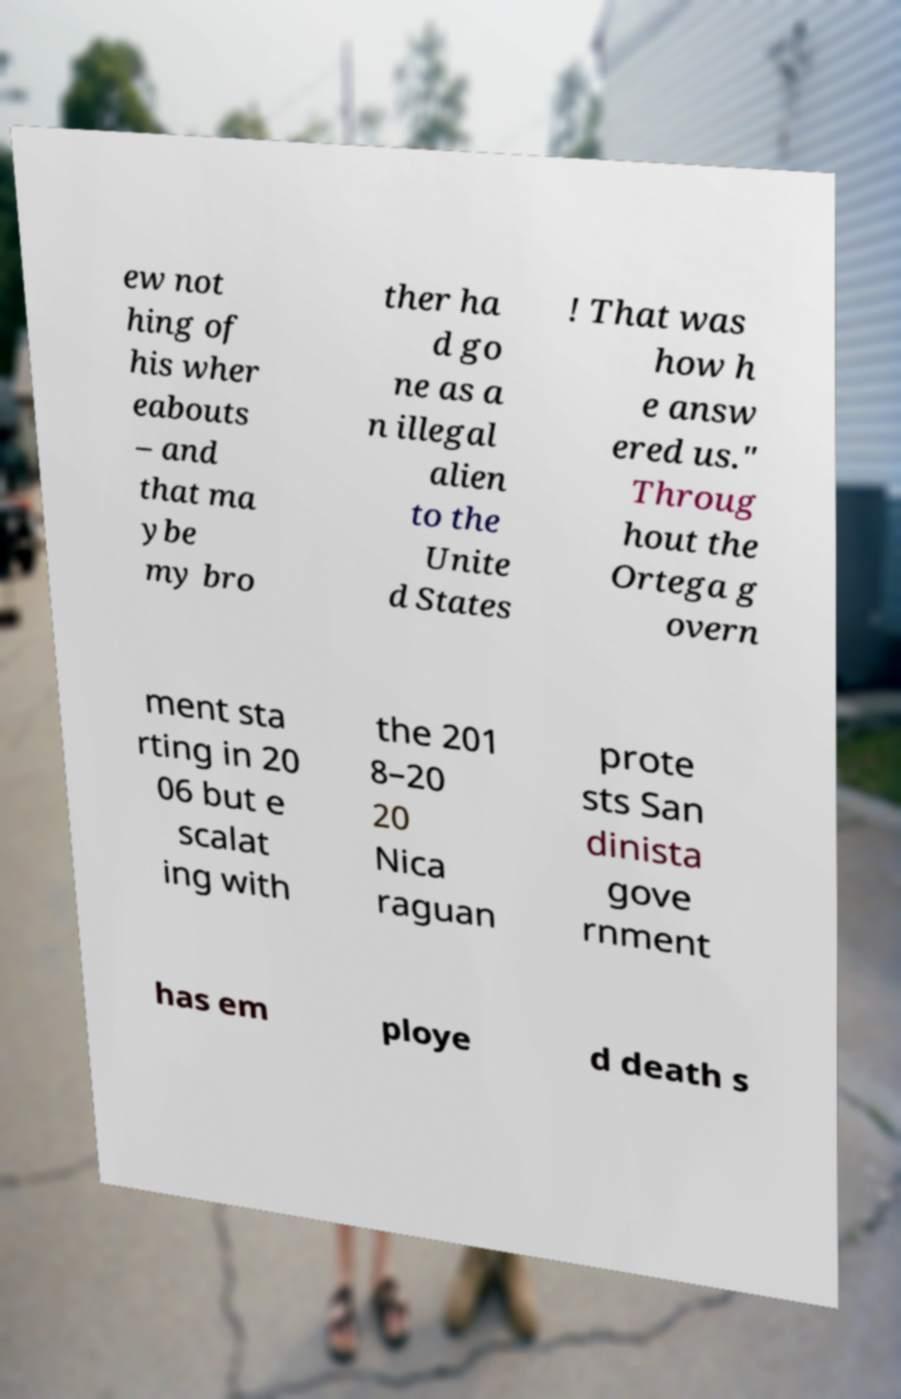Could you assist in decoding the text presented in this image and type it out clearly? ew not hing of his wher eabouts – and that ma ybe my bro ther ha d go ne as a n illegal alien to the Unite d States ! That was how h e answ ered us." Throug hout the Ortega g overn ment sta rting in 20 06 but e scalat ing with the 201 8–20 20 Nica raguan prote sts San dinista gove rnment has em ploye d death s 